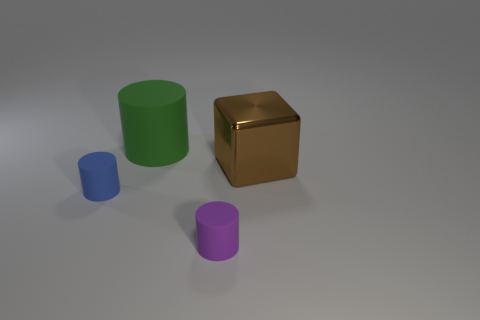Is the color of the large matte cylinder the same as the metal block?
Make the answer very short. No. How many other things are the same shape as the large green rubber thing?
Offer a terse response. 2. How many purple objects are either metal objects or tiny rubber objects?
Provide a succinct answer. 1. There is another tiny cylinder that is the same material as the blue cylinder; what color is it?
Your answer should be very brief. Purple. Is the material of the big object that is right of the green rubber thing the same as the cylinder behind the tiny blue matte thing?
Your answer should be compact. No. What is the large object to the right of the large rubber thing made of?
Offer a very short reply. Metal. Does the tiny purple matte object that is in front of the brown object have the same shape as the small object behind the small purple cylinder?
Your answer should be compact. Yes. Are any rubber things visible?
Provide a short and direct response. Yes. What is the material of the big green object that is the same shape as the small blue thing?
Provide a short and direct response. Rubber. Are there any blue objects in front of the brown metal block?
Your response must be concise. Yes. 